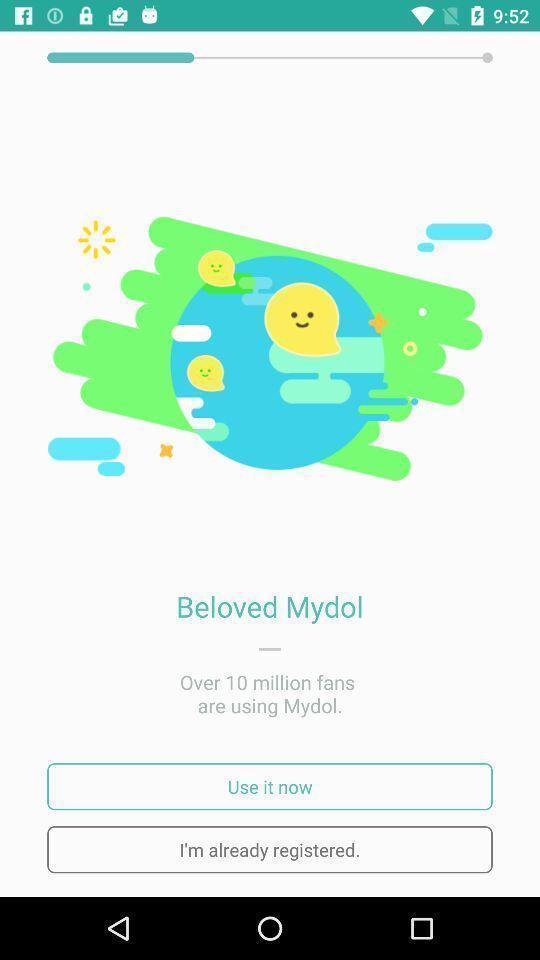Summarize the main components in this picture. Welcome page. 